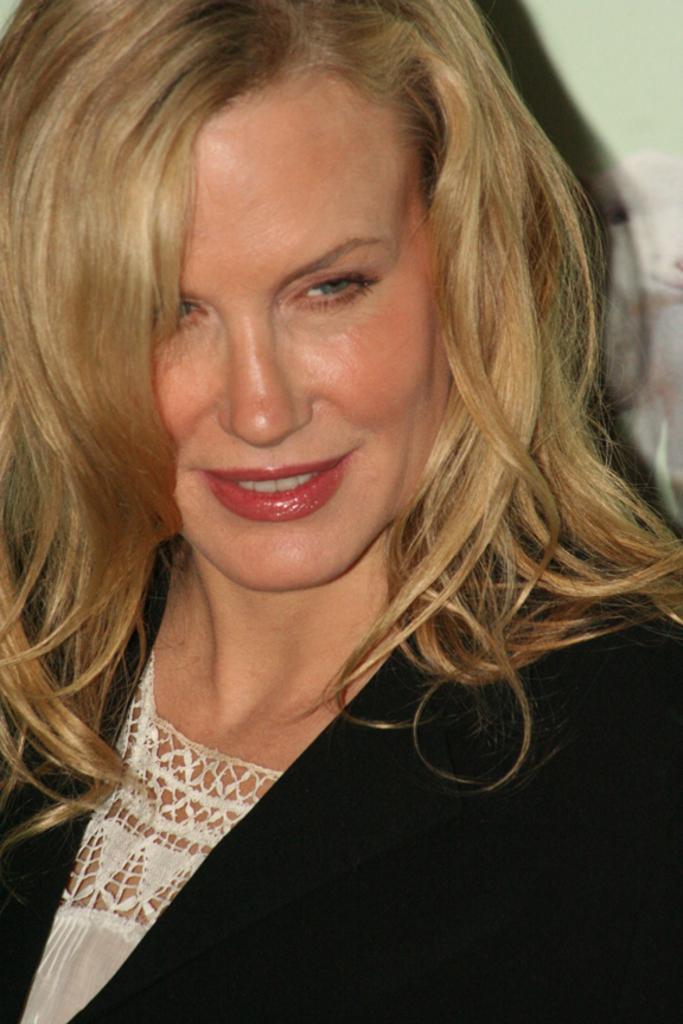Can you describe this image briefly? This picture shows a woman with a smile on her face and she wore a black coat. 